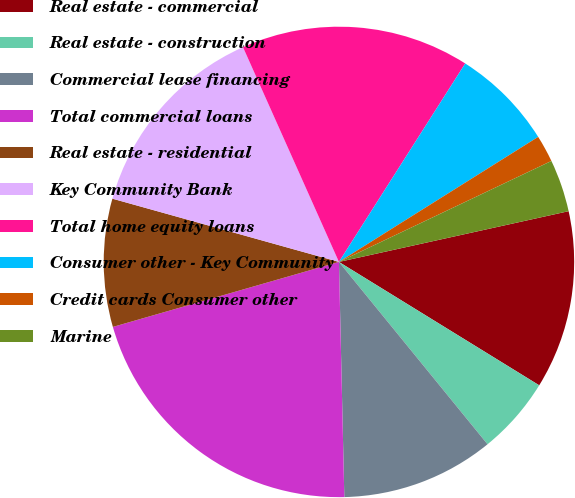<chart> <loc_0><loc_0><loc_500><loc_500><pie_chart><fcel>Real estate - commercial<fcel>Real estate - construction<fcel>Commercial lease financing<fcel>Total commercial loans<fcel>Real estate - residential<fcel>Key Community Bank<fcel>Total home equity loans<fcel>Consumer other - Key Community<fcel>Credit cards Consumer other<fcel>Marine<nl><fcel>12.25%<fcel>5.33%<fcel>10.52%<fcel>20.91%<fcel>8.79%<fcel>13.98%<fcel>15.71%<fcel>7.06%<fcel>1.86%<fcel>3.6%<nl></chart> 